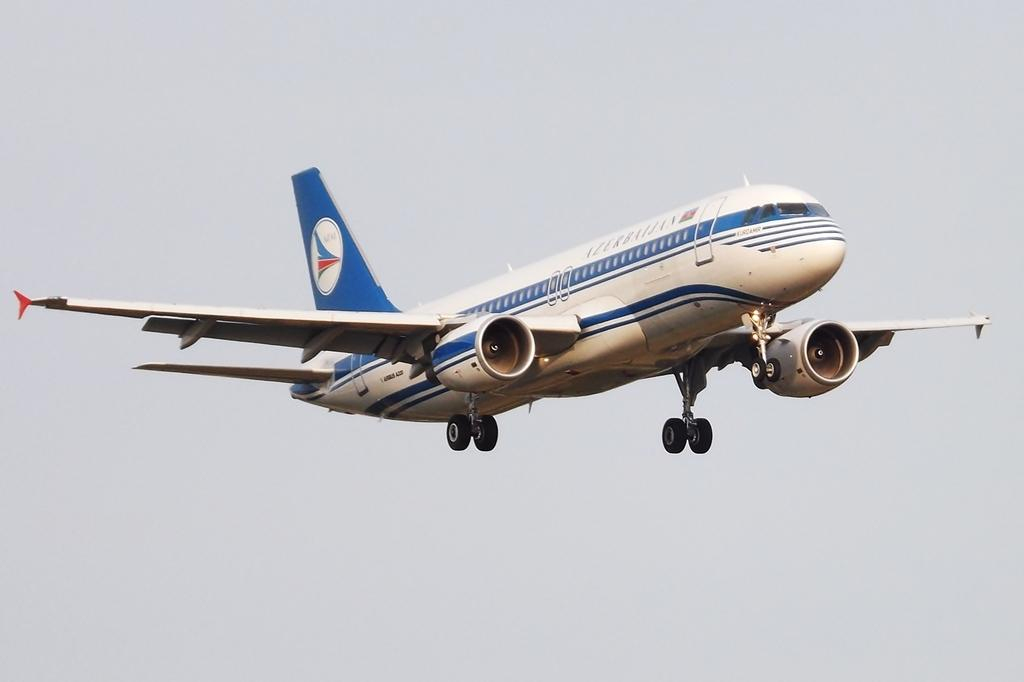What is the main subject of the image? The main subject of the image is an airplane. What is the airplane doing in the image? The airplane is flying in the air. What can be seen above the airplane in the image? The sky is visible above the airplane. What type of skirt is the airplane wearing in the image? Airplanes do not wear skirts; they are inanimate objects. 